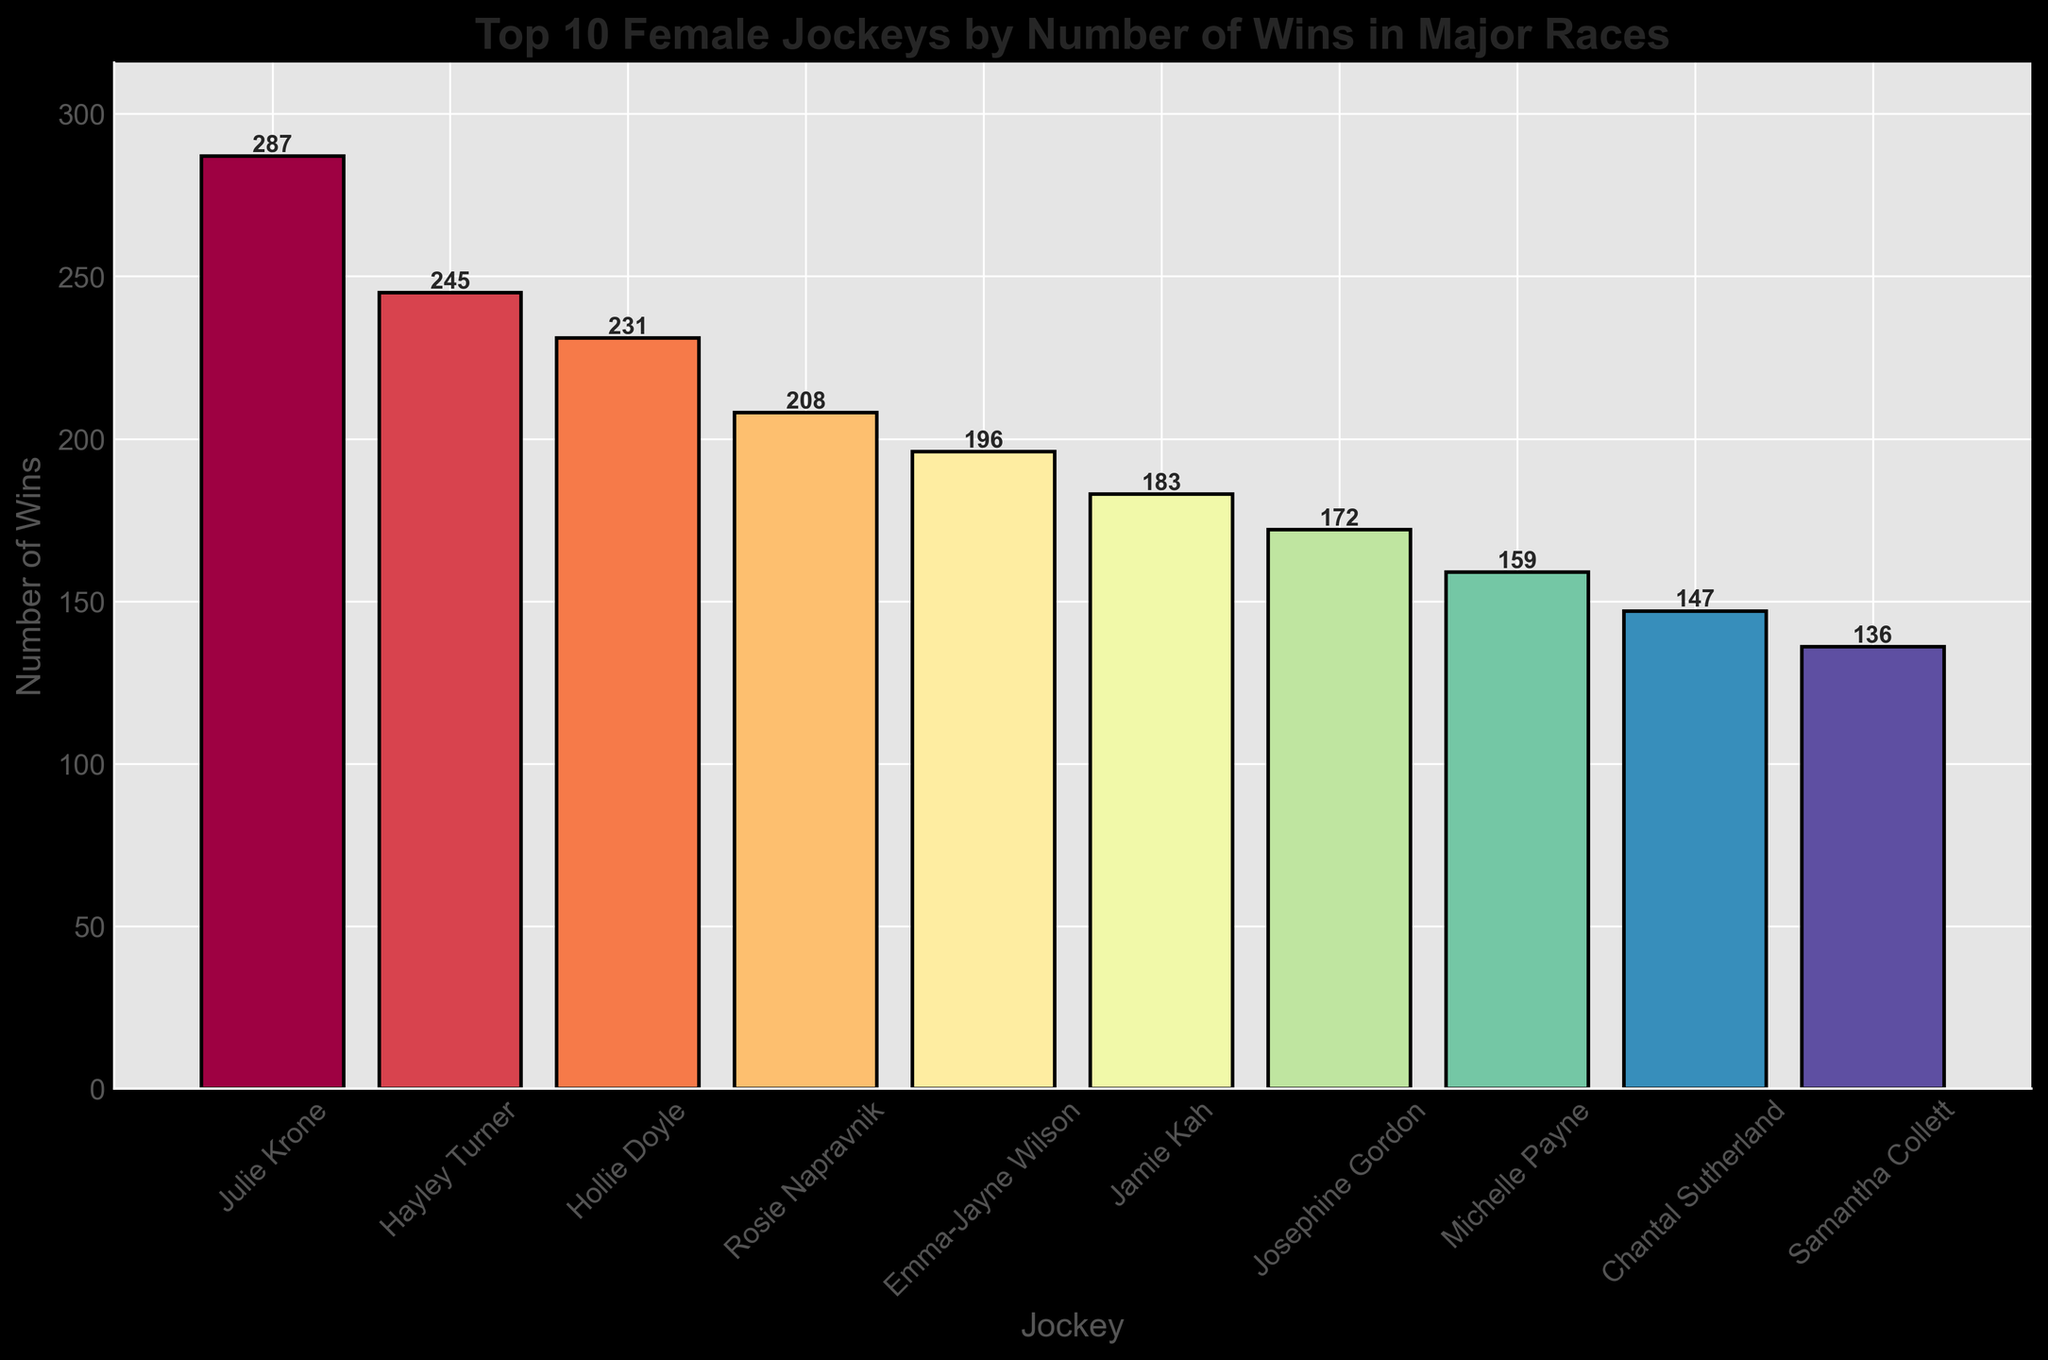Which female jockey has the highest number of wins? The jockey with the tallest bar represents the highest number of wins. Julie Krone's bar is the tallest.
Answer: Julie Krone How many more wins does Julie Krone have compared to Hayley Turner? Find the difference between Julie Krone's wins (287) and Hayley Turner's wins (245). 287 - 245 = 42.
Answer: 42 Who has more wins, Emma-Jayne Wilson or Michelle Payne? Compare the heights of the bars corresponding to Emma-Jayne Wilson (196) and Michelle Payne (159). Emma-Jayne Wilson's bar is taller.
Answer: Emma-Jayne Wilson What's the total number of wins for the top 3 jockeys? Sum the wins of Julie Krone (287), Hayley Turner (245), and Hollie Doyle (231). 287 + 245 + 231 = 763.
Answer: 763 What is the average number of wins among the top 10 female jockeys? Sum all the wins and divide by the number of jockeys. Total wins: (287 + 245 + 231 + 208 + 196 + 183 + 172 + 159 + 147 + 136) = 1964. Average = 1964 / 10 = 196.4.
Answer: 196.4 What is the difference in wins between the third and fourth top jockeys? Subtract the wins of the fourth jockey (Rosie Napravnik, 208) from the third jockey (Hollie Doyle, 231). 231 - 208 = 23.
Answer: 23 Which jockey has the fewest wins among the top 10? Identify the jockey with the shortest bar. Samantha Collett has the shortest bar with 136 wins.
Answer: Samantha Collett Does Jamie Kah or Chantal Sutherland have more wins? Compare the heights of the bars corresponding to Jamie Kah (183) and Chantal Sutherland (147). Jamie Kah's bar is taller.
Answer: Jamie Kah What is the combined total of wins for the jockeys ranked 5th and 6th? Sum the wins of Emma-Jayne Wilson (196) and Jamie Kah (183). 196 + 183 = 379.
Answer: 379 